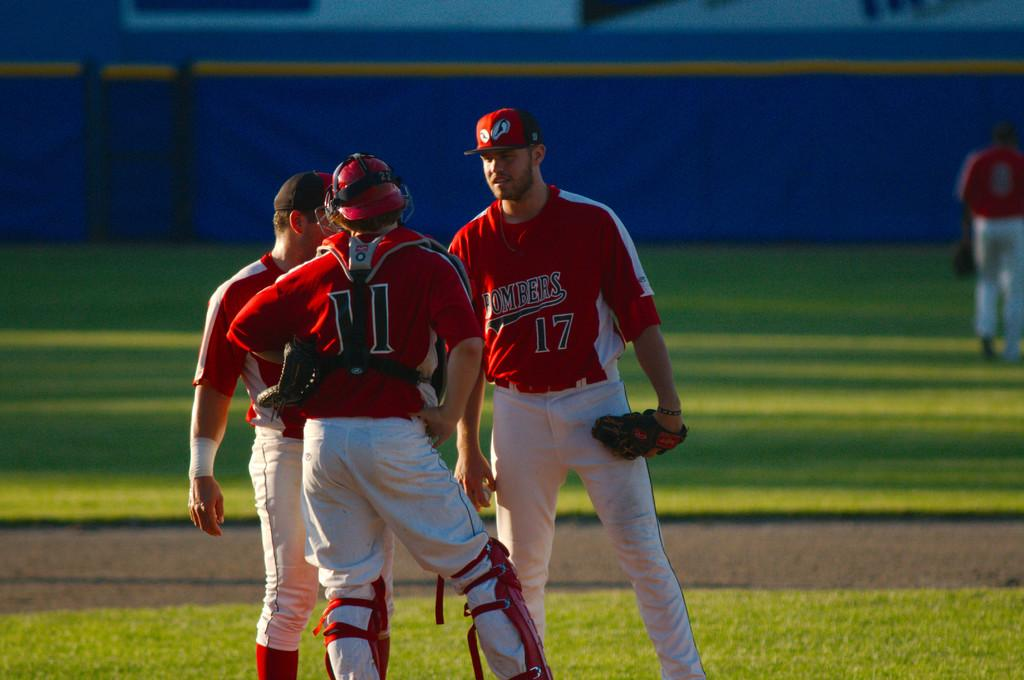<image>
Give a short and clear explanation of the subsequent image. The BOMBERS are sporting their red and black outfits today.. 